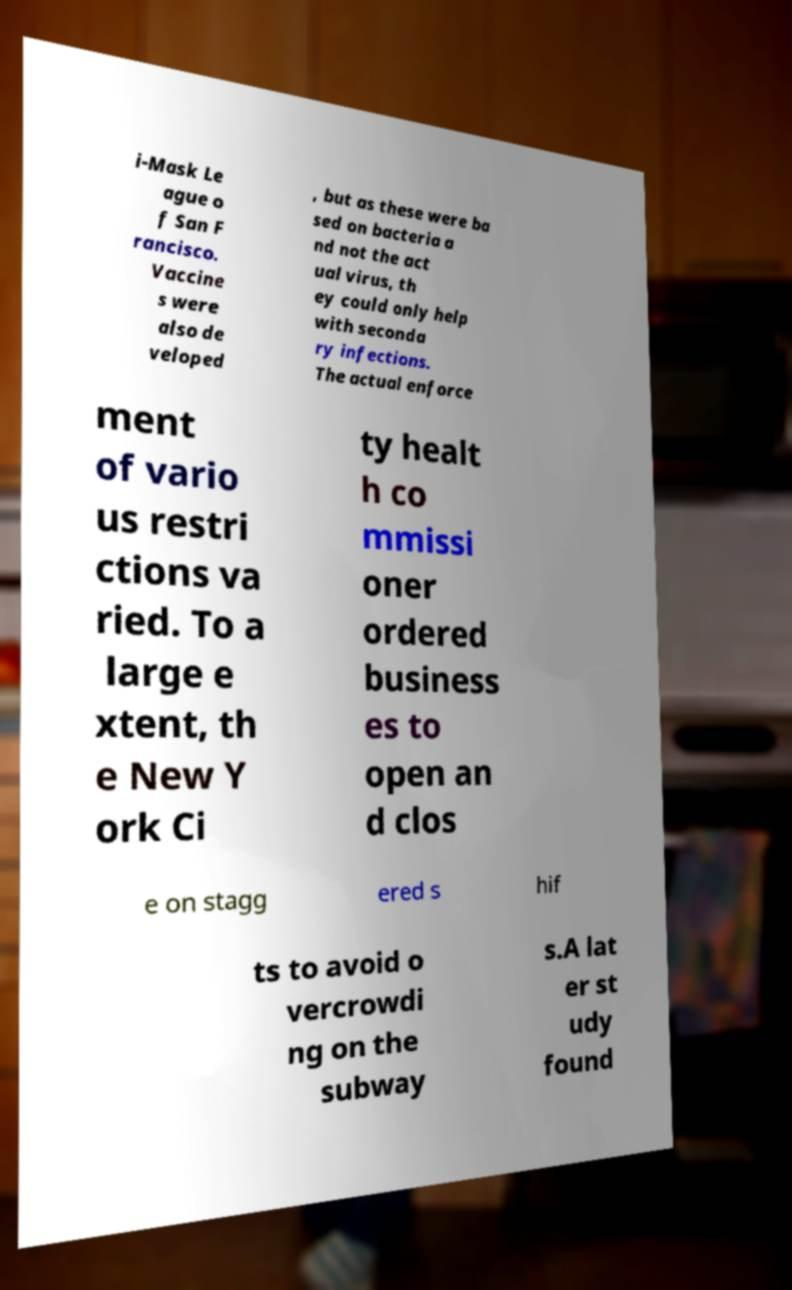Can you accurately transcribe the text from the provided image for me? i-Mask Le ague o f San F rancisco. Vaccine s were also de veloped , but as these were ba sed on bacteria a nd not the act ual virus, th ey could only help with seconda ry infections. The actual enforce ment of vario us restri ctions va ried. To a large e xtent, th e New Y ork Ci ty healt h co mmissi oner ordered business es to open an d clos e on stagg ered s hif ts to avoid o vercrowdi ng on the subway s.A lat er st udy found 